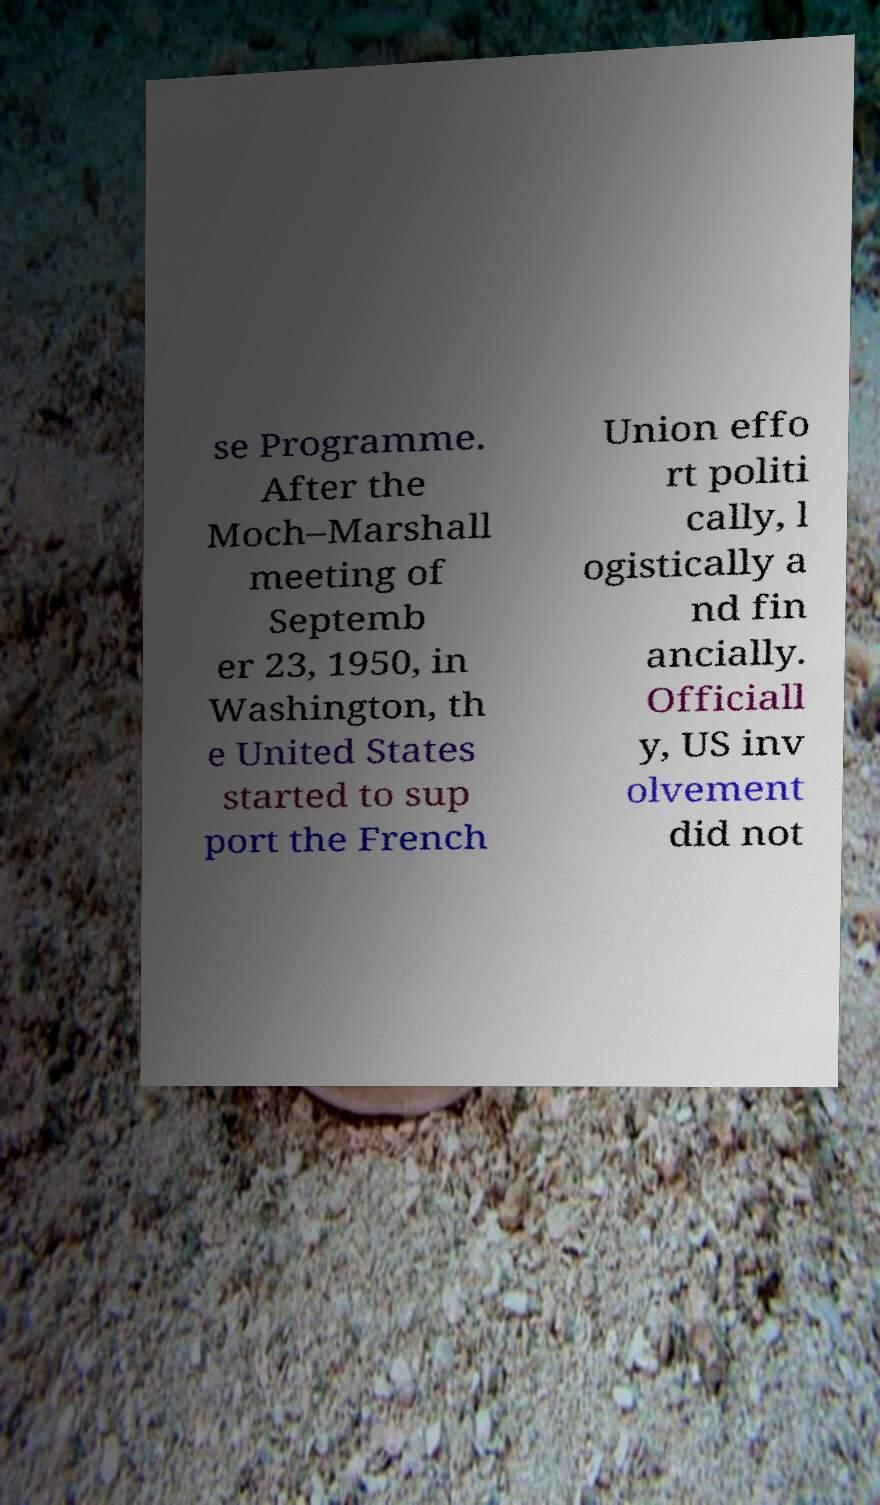Please identify and transcribe the text found in this image. se Programme. After the Moch–Marshall meeting of Septemb er 23, 1950, in Washington, th e United States started to sup port the French Union effo rt politi cally, l ogistically a nd fin ancially. Officiall y, US inv olvement did not 